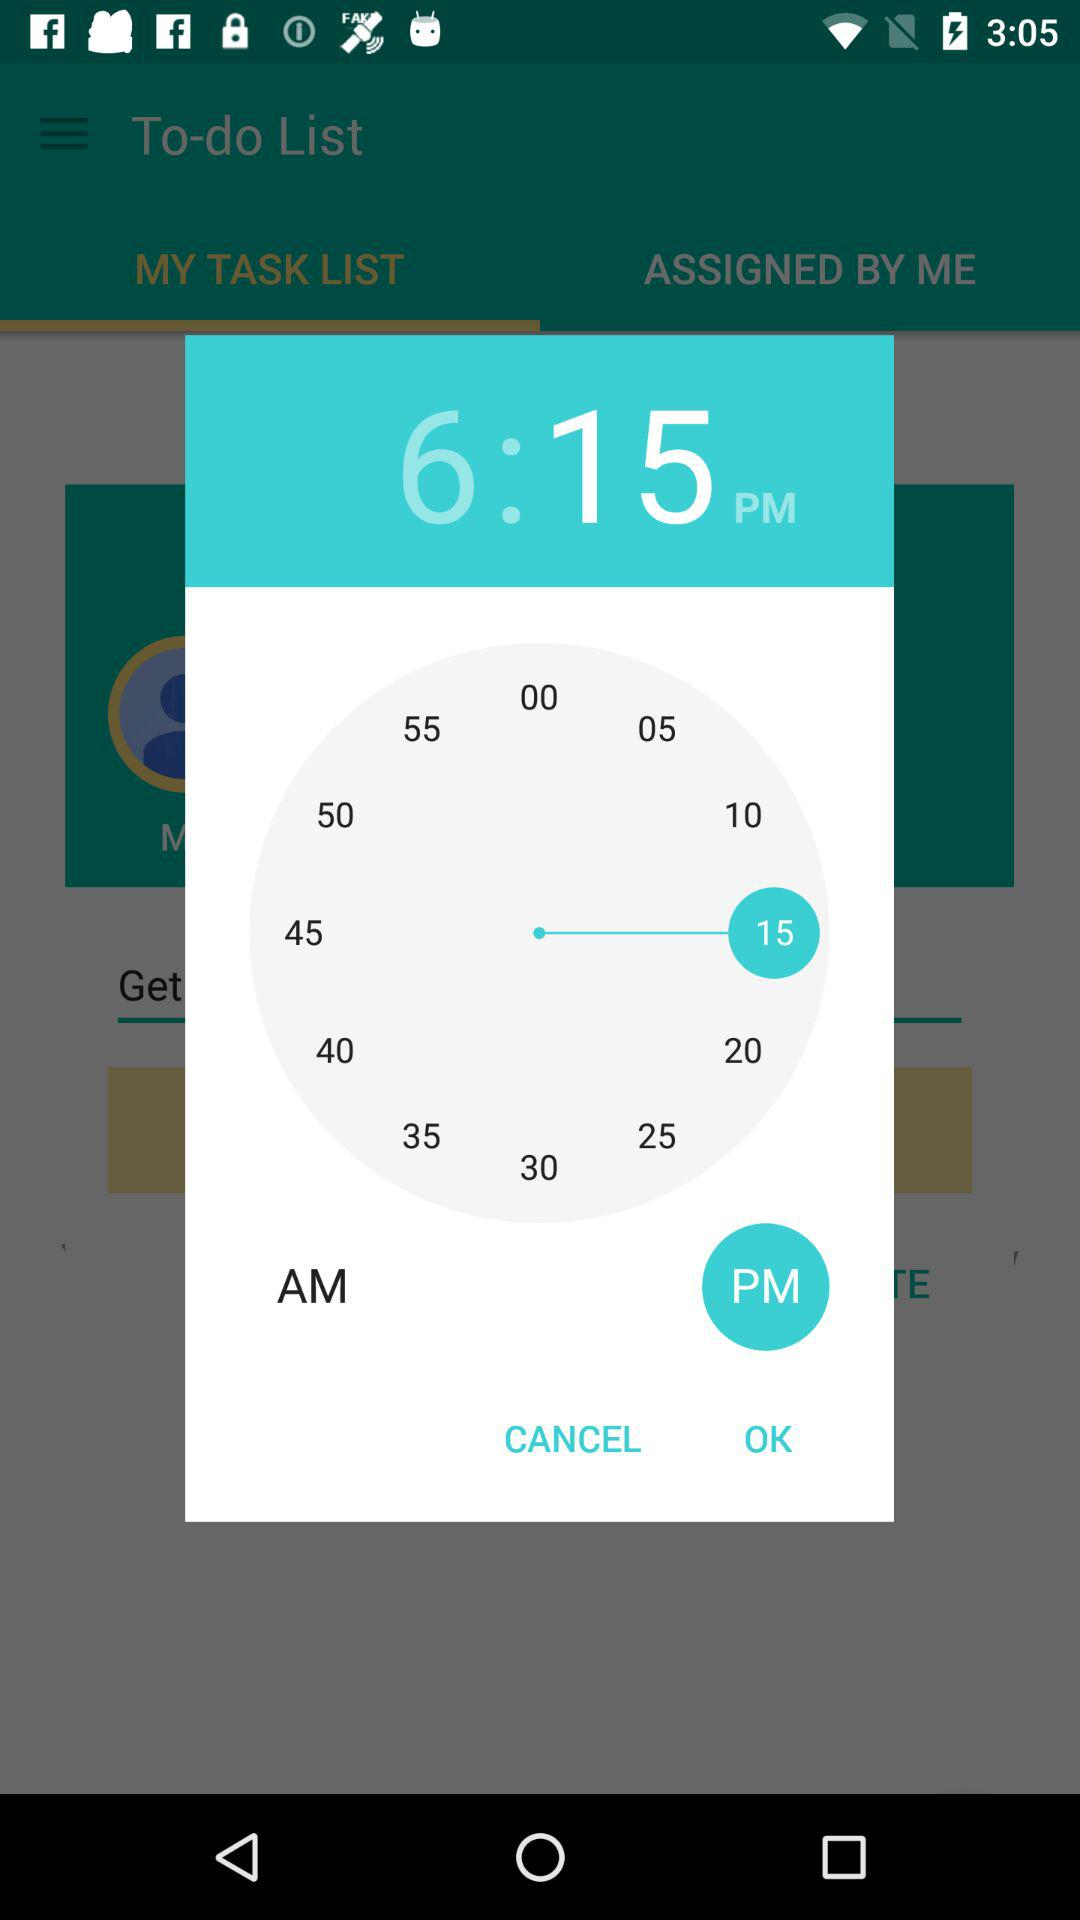Is it PM or AM?
Answer the question using a single word or phrase. It is PM. 